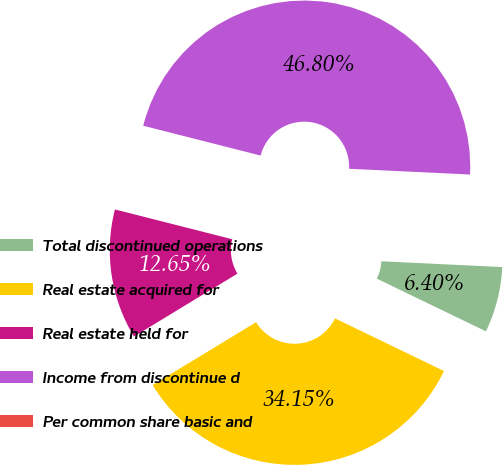Convert chart to OTSL. <chart><loc_0><loc_0><loc_500><loc_500><pie_chart><fcel>Total discontinued operations<fcel>Real estate acquired for<fcel>Real estate held for<fcel>Income from discontinue d<fcel>Per common share basic and<nl><fcel>6.4%<fcel>34.15%<fcel>12.65%<fcel>46.8%<fcel>0.0%<nl></chart> 